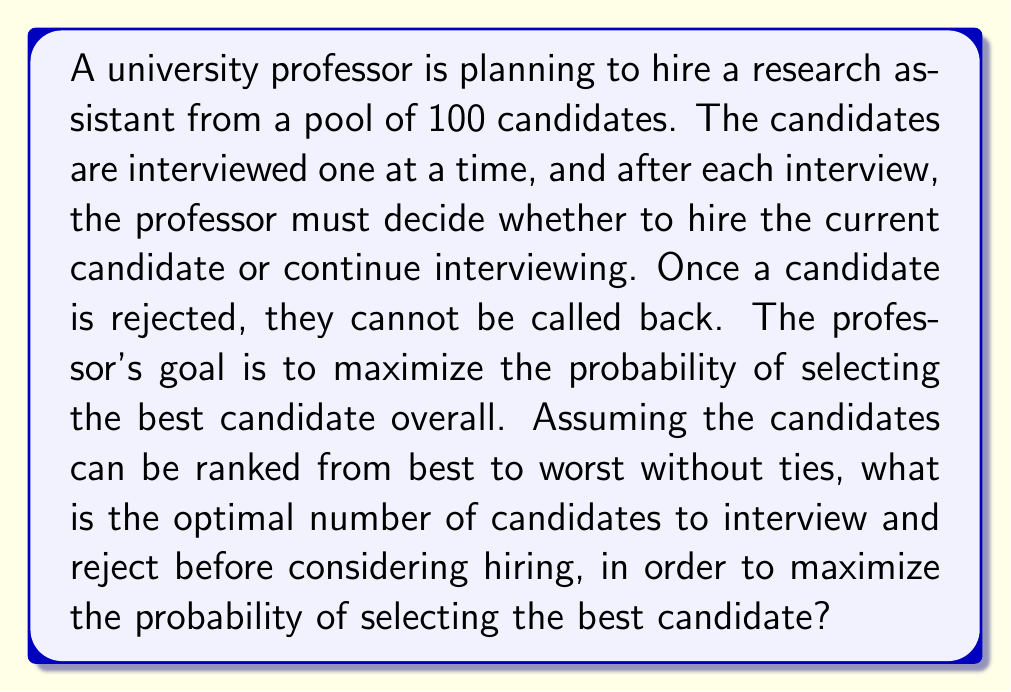Provide a solution to this math problem. This problem is a classic example of the Secretary Problem in optimal stopping theory. To solve it, we follow these steps:

1) Let $n$ be the total number of candidates (in this case, $n = 100$).

2) Let $k$ be the number of candidates to interview and reject before considering hiring.

3) The probability of success (hiring the best candidate) is:

   $$P(\text{success}) = \frac{k}{n} \sum_{i=k+1}^n \frac{1}{i-1}$$

4) To find the optimal $k$, we need to maximize this probability. In practice, for large $n$, the optimal $k$ approaches $n/e$, where $e$ is Euler's number.

5) For $n = 100$, the optimal $k$ is approximately:

   $$k \approx \frac{100}{e} \approx 36.79$$

6) Since $k$ must be an integer, we round to the nearest whole number: 37.

7) To verify, we can calculate the probability of success for $k = 36, 37, 38$:

   For $k = 36$: $P(\text{success}) \approx 0.3711$
   For $k = 37$: $P(\text{success}) \approx 0.3712$
   For $k = 38$: $P(\text{success}) \approx 0.3711$

8) This confirms that $k = 37$ gives the highest probability of success.

Therefore, the optimal strategy is to interview and reject the first 37 candidates, then hire the next candidate who is better than all those seen so far (or the last candidate if no one better is found).
Answer: The optimal number of candidates to interview and reject before considering hiring is 37. 